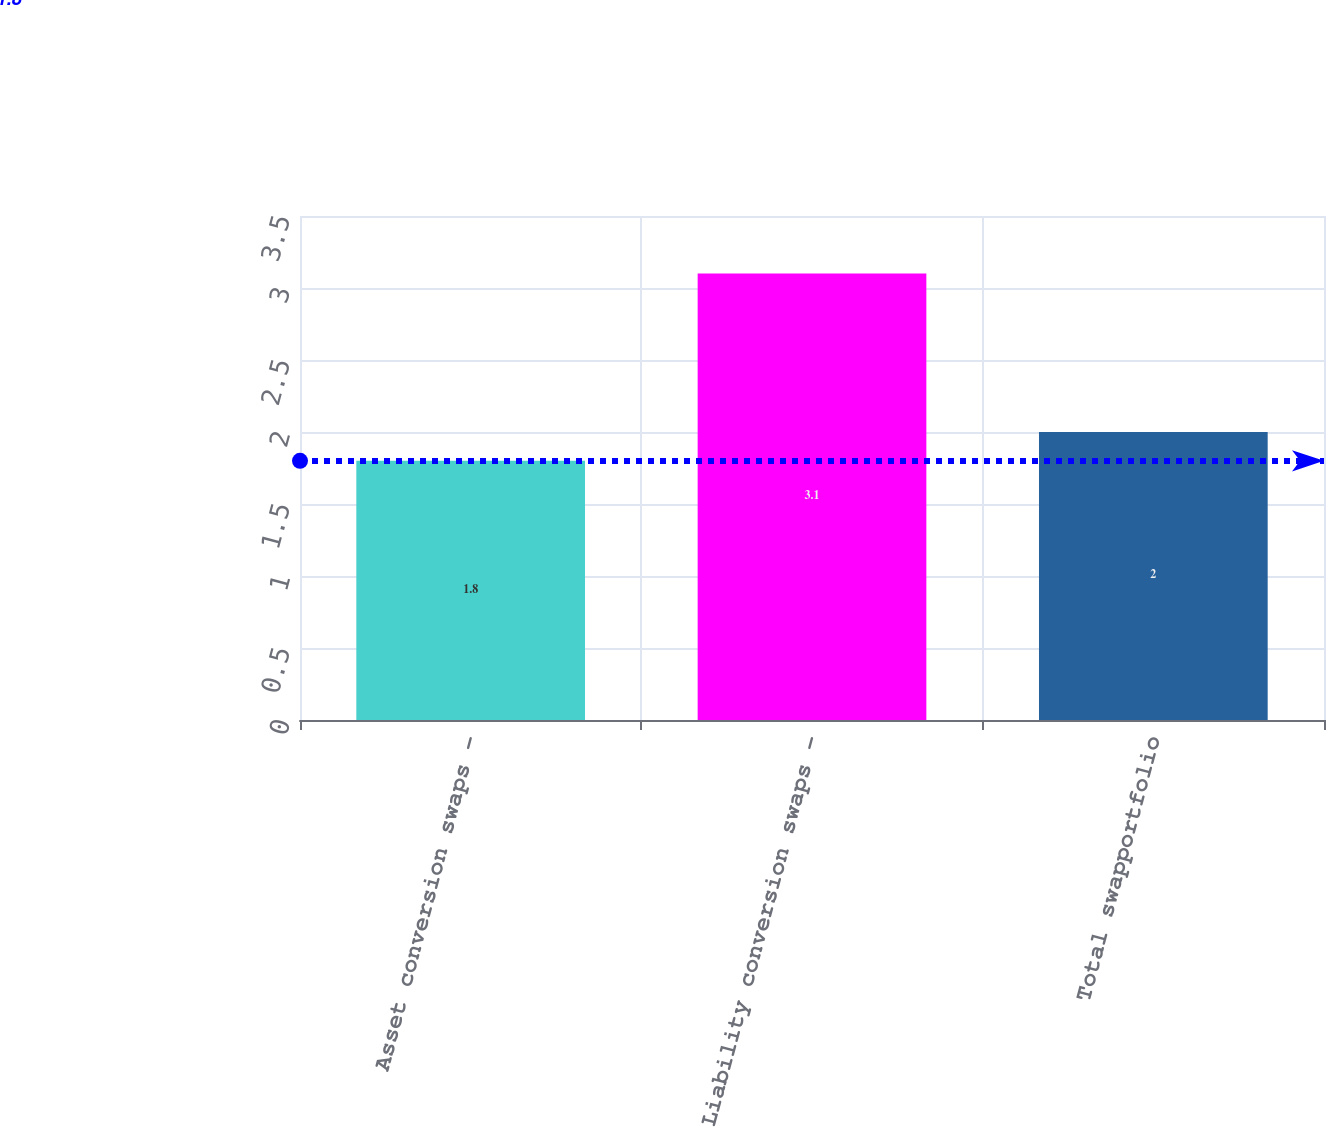Convert chart. <chart><loc_0><loc_0><loc_500><loc_500><bar_chart><fcel>Asset conversion swaps -<fcel>Liability conversion swaps -<fcel>Total swapportfolio<nl><fcel>1.8<fcel>3.1<fcel>2<nl></chart> 